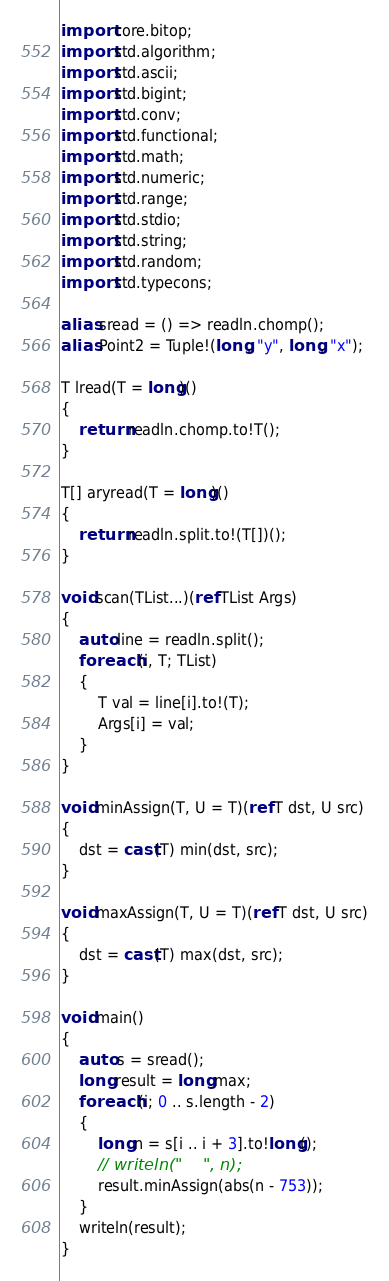Convert code to text. <code><loc_0><loc_0><loc_500><loc_500><_D_>import core.bitop;
import std.algorithm;
import std.ascii;
import std.bigint;
import std.conv;
import std.functional;
import std.math;
import std.numeric;
import std.range;
import std.stdio;
import std.string;
import std.random;
import std.typecons;

alias sread = () => readln.chomp();
alias Point2 = Tuple!(long, "y", long, "x");

T lread(T = long)()
{
    return readln.chomp.to!T();
}

T[] aryread(T = long)()
{
    return readln.split.to!(T[])();
}

void scan(TList...)(ref TList Args)
{
    auto line = readln.split();
    foreach (i, T; TList)
    {
        T val = line[i].to!(T);
        Args[i] = val;
    }
}

void minAssign(T, U = T)(ref T dst, U src)
{
    dst = cast(T) min(dst, src);
}

void maxAssign(T, U = T)(ref T dst, U src)
{
    dst = cast(T) max(dst, src);
}

void main()
{
    auto s = sread();
    long result = long.max;
    foreach (i; 0 .. s.length - 2)
    {
        long n = s[i .. i + 3].to!long();
        // writeln("    ", n);
        result.minAssign(abs(n - 753));
    }
    writeln(result);
}
</code> 